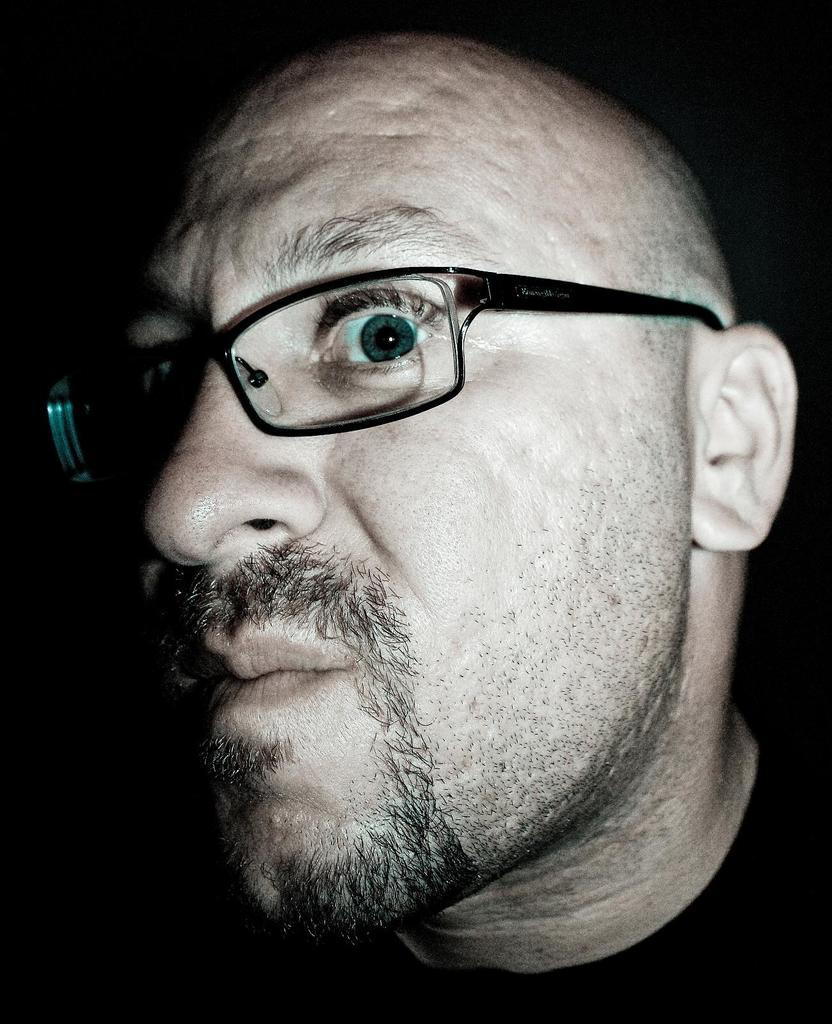What is the main subject of the image? The main subject of the image is a man's face. What can be seen on the man's face in the image? The man is wearing spectacles in the image. What type of slope can be seen in the background of the image? There is no slope present in the image; it only features a man's face with spectacles. 